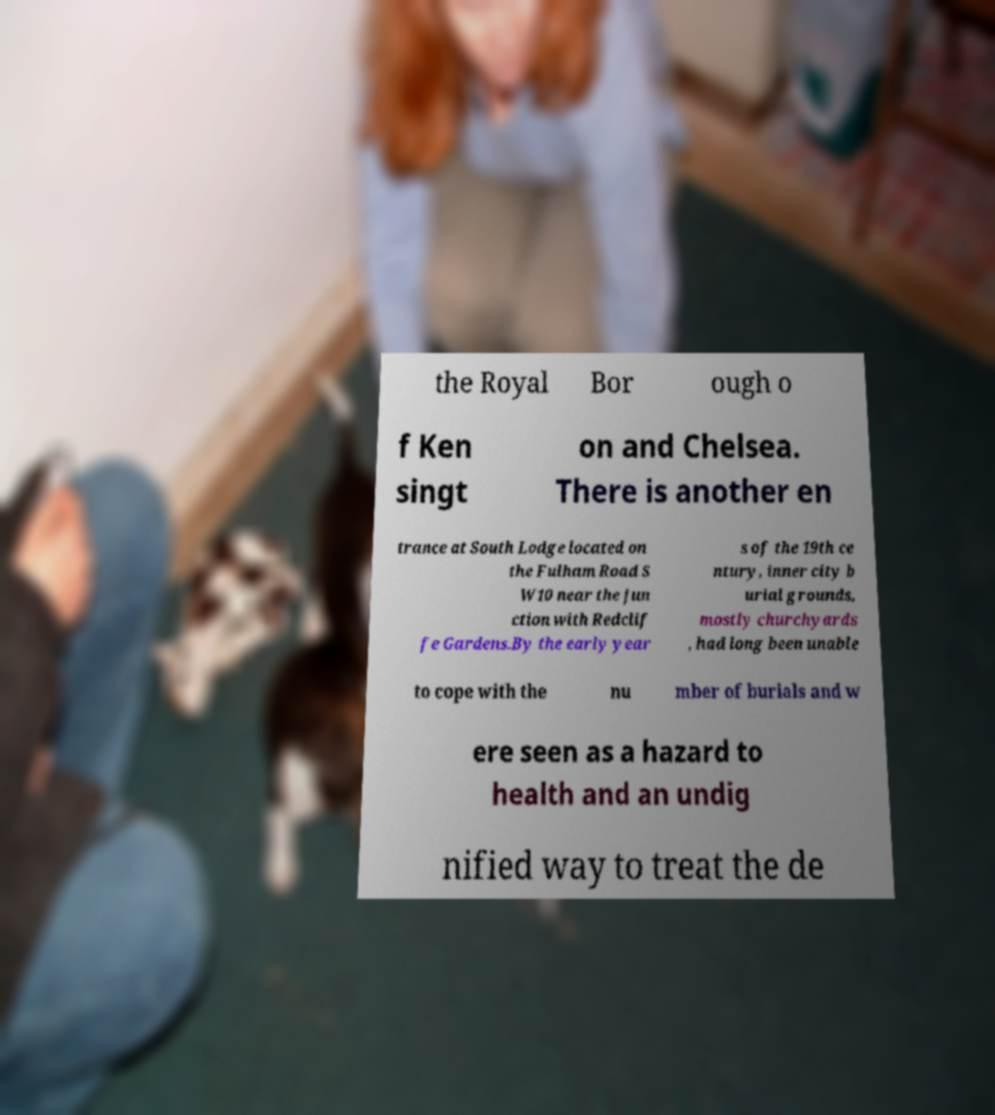Could you extract and type out the text from this image? the Royal Bor ough o f Ken singt on and Chelsea. There is another en trance at South Lodge located on the Fulham Road S W10 near the jun ction with Redclif fe Gardens.By the early year s of the 19th ce ntury, inner city b urial grounds, mostly churchyards , had long been unable to cope with the nu mber of burials and w ere seen as a hazard to health and an undig nified way to treat the de 